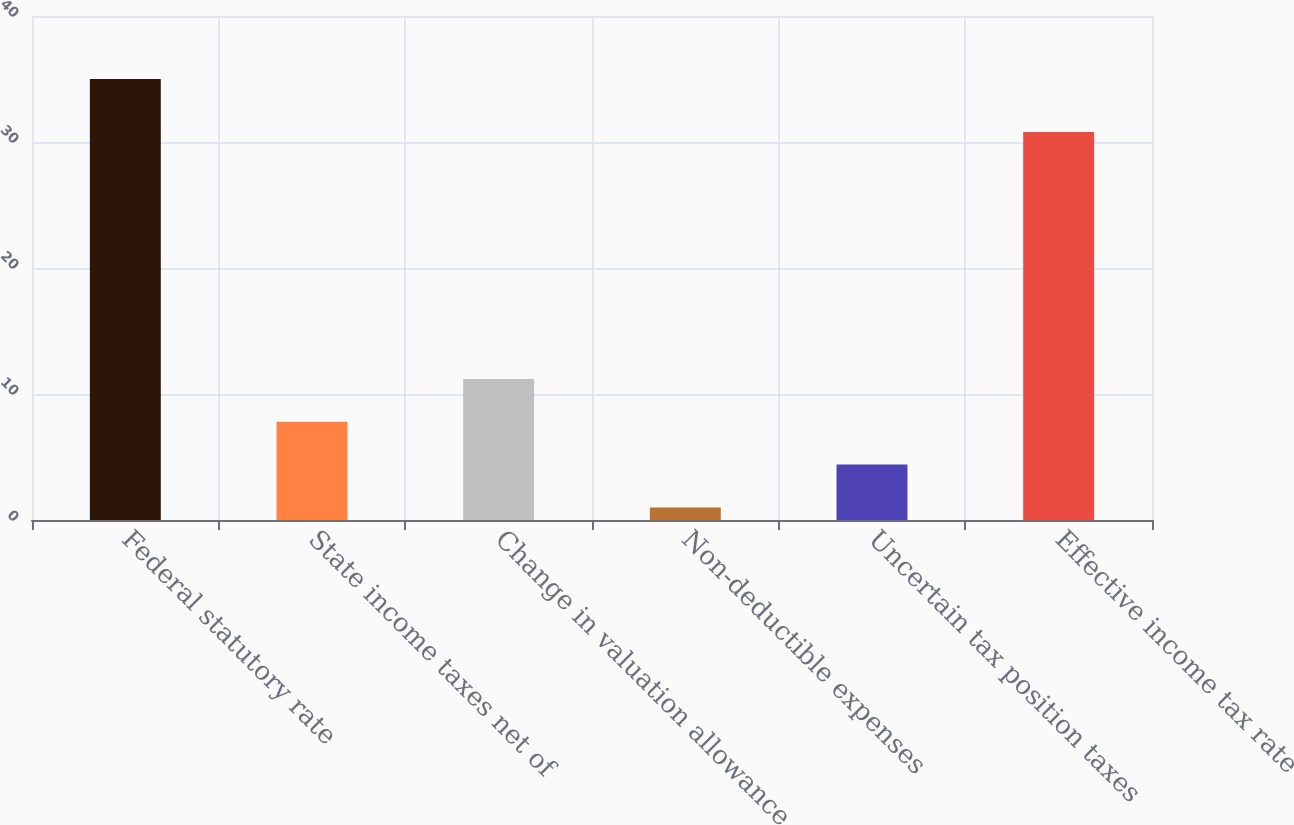Convert chart. <chart><loc_0><loc_0><loc_500><loc_500><bar_chart><fcel>Federal statutory rate<fcel>State income taxes net of<fcel>Change in valuation allowance<fcel>Non-deductible expenses<fcel>Uncertain tax position taxes<fcel>Effective income tax rate<nl><fcel>35<fcel>7.8<fcel>11.2<fcel>1<fcel>4.4<fcel>30.8<nl></chart> 